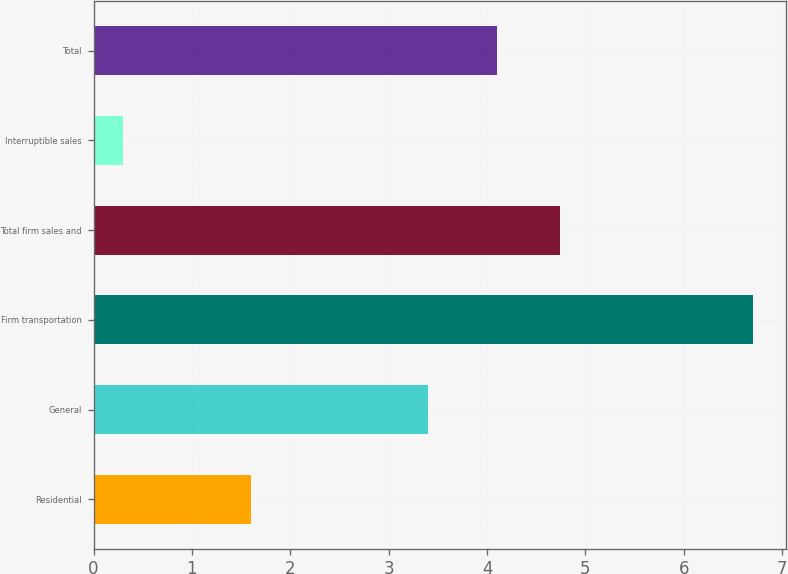Convert chart to OTSL. <chart><loc_0><loc_0><loc_500><loc_500><bar_chart><fcel>Residential<fcel>General<fcel>Firm transportation<fcel>Total firm sales and<fcel>Interruptible sales<fcel>Total<nl><fcel>1.6<fcel>3.4<fcel>6.7<fcel>4.74<fcel>0.3<fcel>4.1<nl></chart> 